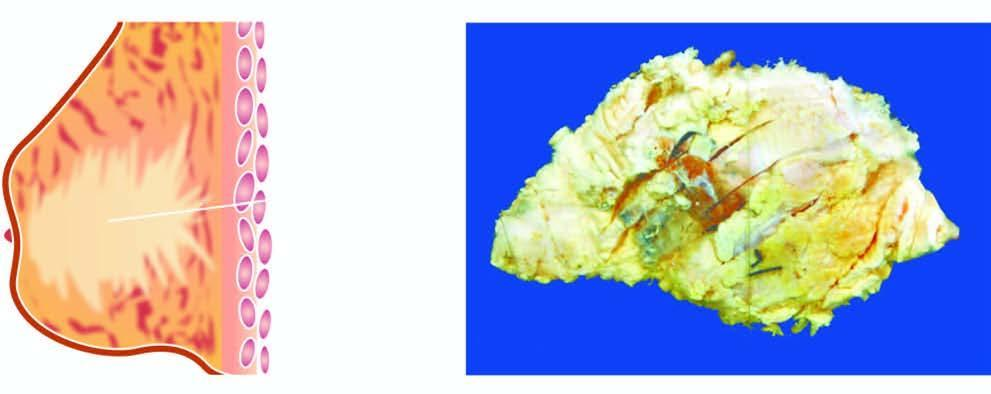what shows a tumour extending up to nipple and areola?
Answer the question using a single word or phrase. Breast 